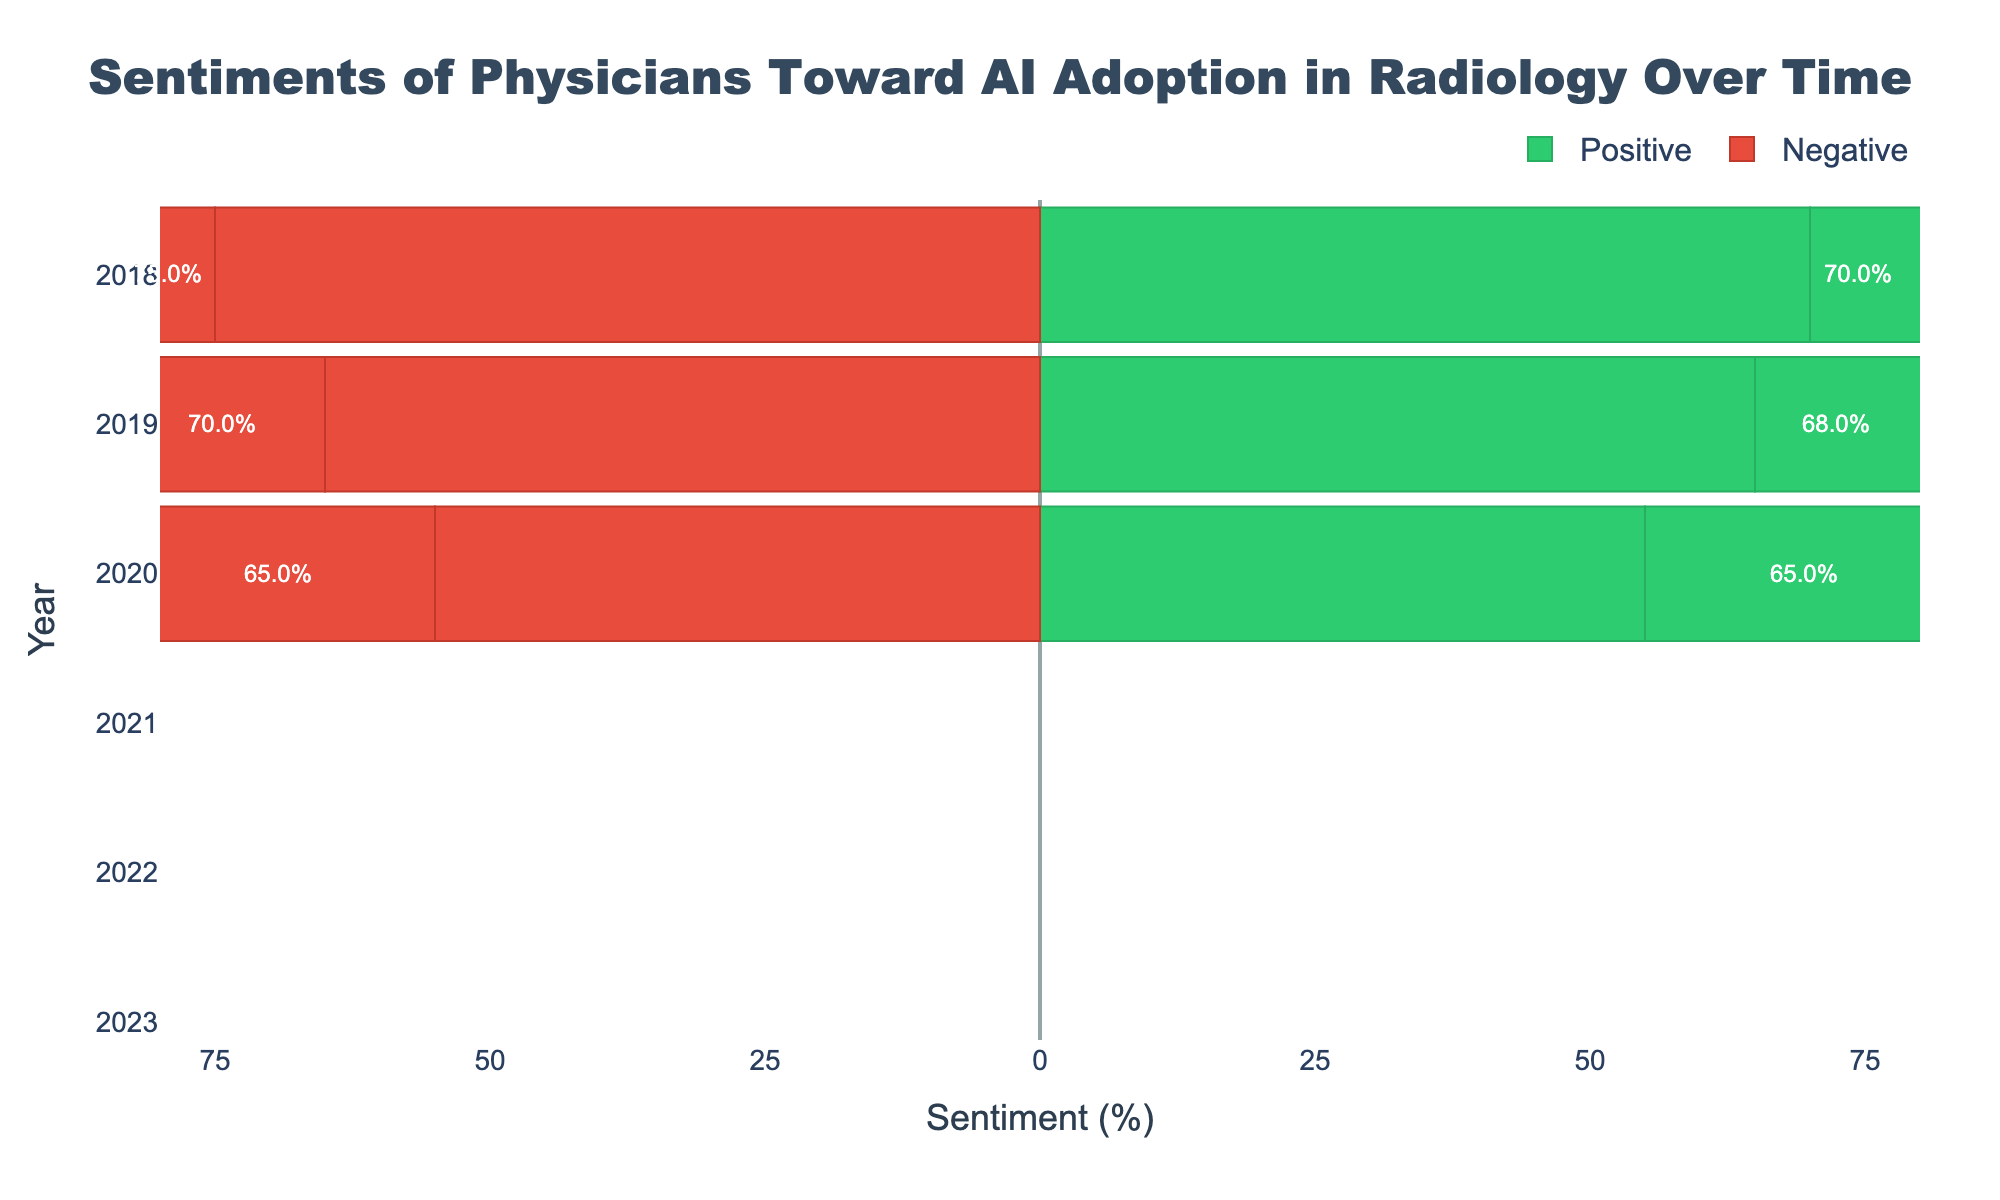What was the sentiment ratio in 2018? In 2018, the positive sentiment was 70% and the negative sentiment was 75%. As sentiments are divided into "Positive" and "Negative," we look at the values of each sentiment in the specified year.
Answer: Positive: 70%, Negative: 75% How did the negative sentiment change from 2018 to 2023? To determine the change in negative sentiment from 2018 to 2023, we subtract the initial value in 2018 (75%) from the final value in 2023 (55%): 75% - 55% = 20%.
Answer: Decreased by 20% What is the average positive sentiment from 2018 to 2023? The positive sentiments from 2018 to 2023 are: 70%, 68%, 65%, 60%, 55%, and 50%. The average is calculated by summing these values and dividing by the number of years: (70 + 68 + 65 + 60 + 55 + 50) / 6 = 61.3%.
Answer: 61.3% Which year had the highest negative sentiment and what was it? Looking at the data, 2018 had the highest negative sentiment at 75%. We compare the negative sentiment values across all years to identify the highest.
Answer: 2018, 75% What is the trend in positive sentiment from 2018 to 2023? From 2018 to 2023, the positive sentiment shows a decreasing trend: it goes from 70% in 2018 to 50% in 2023. This is seen by examining the yearly positive sentiment values and observing their decline.
Answer: Decreasing Calculate the total negative sentiment over the given years. Summing the negative sentiment values for each year: 75 + 70 + 65 + 60 + 55 + 55 = 380.
Answer: 380% In which year do positive and negative sentiments become equal, and what is the value? In 2023, both positive and negative sentiments are equal at 50%. We look for the year where the positive and negative percentages match.
Answer: 2023, 50% How much did the positive sentiment decrease from 2019 to 2021? The positive sentiment in 2019 was 68%, and in 2021, it was 60%. Subtract the value in 2021 from that in 2019: 68% - 60% = 8%.
Answer: Decreased by 8% What is the average negative sentiment over the last three years (2021-2023)? The negative sentiments for the last three years are 60%, 55%, and 55%. The average is calculated by summing these values and dividing by 3: (60 + 55 + 55) / 3 = 56.7%.
Answer: 56.7% From which year to which year did the positive sentiment experience the largest drop? The positive sentiment dropped from 65% in 2020 to 60% in 2021, a decrease of 5%, which is the largest single-year drop.
Answer: 2020 to 2021 